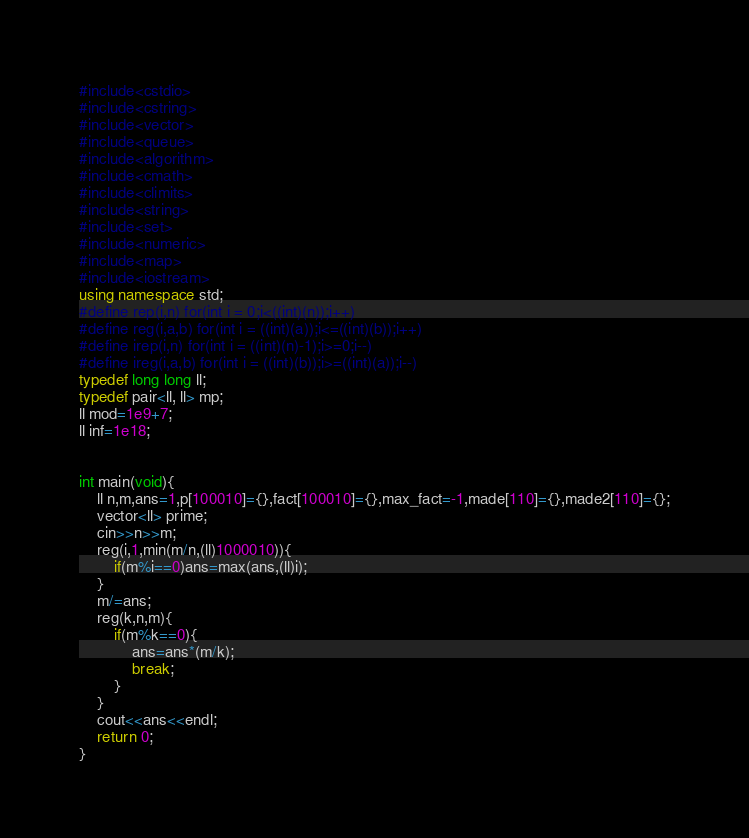Convert code to text. <code><loc_0><loc_0><loc_500><loc_500><_C++_>#include<cstdio>
#include<cstring>
#include<vector>
#include<queue>
#include<algorithm>
#include<cmath>
#include<climits>
#include<string>
#include<set>
#include<numeric>
#include<map>
#include<iostream>
using namespace std;
#define rep(i,n) for(int i = 0;i<((int)(n));i++)
#define reg(i,a,b) for(int i = ((int)(a));i<=((int)(b));i++)
#define irep(i,n) for(int i = ((int)(n)-1);i>=0;i--)
#define ireg(i,a,b) for(int i = ((int)(b));i>=((int)(a));i--)
typedef long long ll;
typedef pair<ll, ll> mp;
ll mod=1e9+7;
ll inf=1e18;


int main(void){
	ll n,m,ans=1,p[100010]={},fact[100010]={},max_fact=-1,made[110]={},made2[110]={};
	vector<ll> prime;
	cin>>n>>m;
	reg(i,1,min(m/n,(ll)1000010)){
		if(m%i==0)ans=max(ans,(ll)i);
	}
	m/=ans;
	reg(k,n,m){
		if(m%k==0){
			ans=ans*(m/k);
			break;
		}
	}
	cout<<ans<<endl;
	return 0;
}</code> 